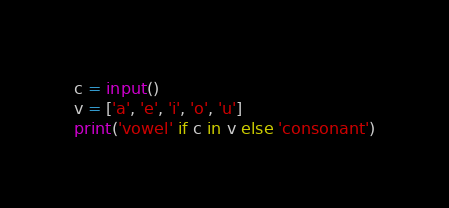<code> <loc_0><loc_0><loc_500><loc_500><_Python_>c = input()
v = ['a', 'e', 'i', 'o', 'u']
print('vowel' if c in v else 'consonant')</code> 